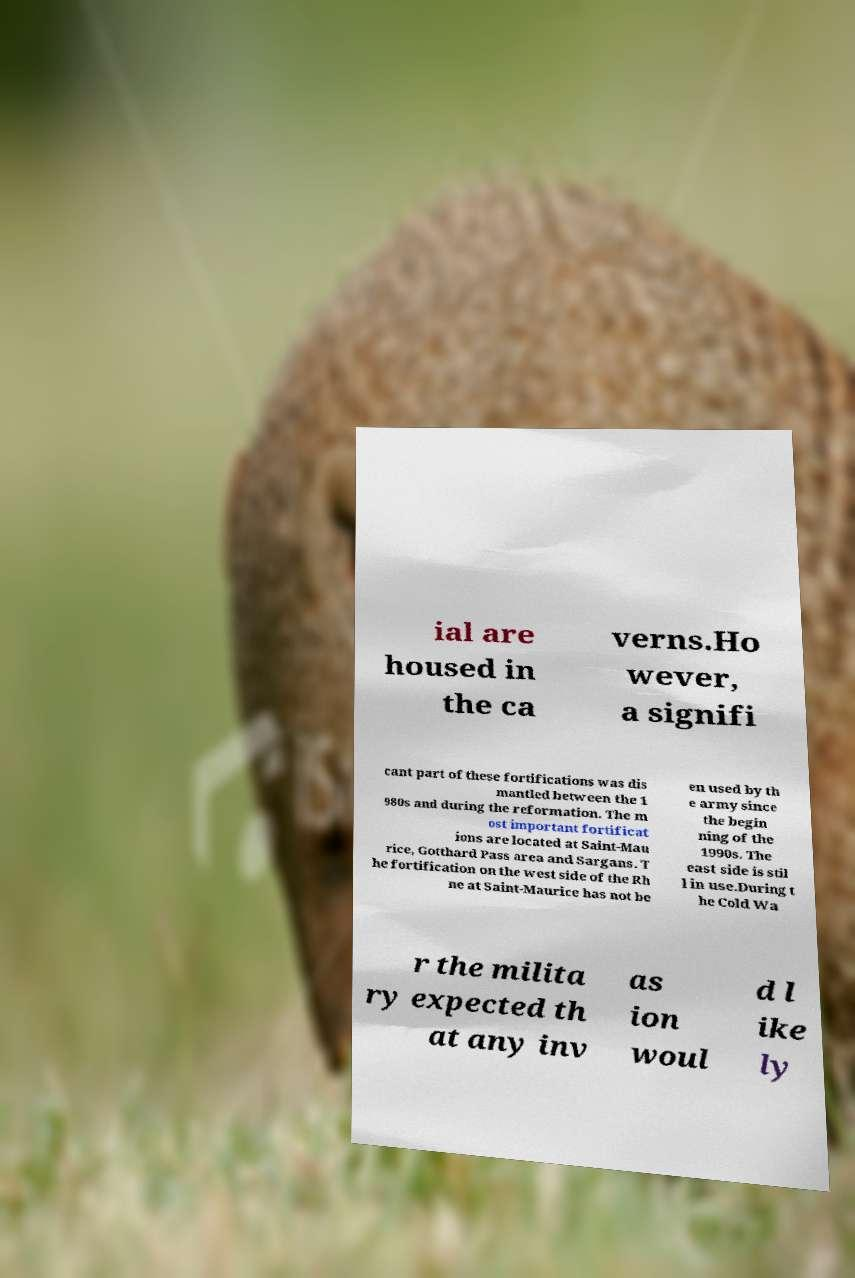I need the written content from this picture converted into text. Can you do that? ial are housed in the ca verns.Ho wever, a signifi cant part of these fortifications was dis mantled between the 1 980s and during the reformation. The m ost important fortificat ions are located at Saint-Mau rice, Gotthard Pass area and Sargans. T he fortification on the west side of the Rh ne at Saint-Maurice has not be en used by th e army since the begin ning of the 1990s. The east side is stil l in use.During t he Cold Wa r the milita ry expected th at any inv as ion woul d l ike ly 